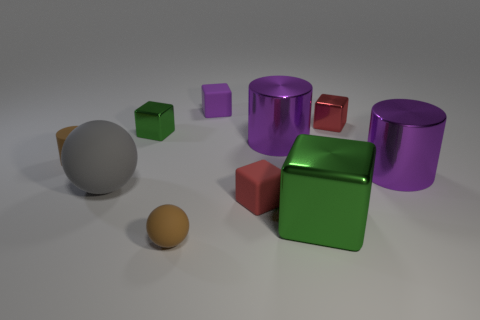What is the material of the small thing that is the same color as the tiny cylinder?
Offer a terse response. Rubber. What is the material of the other thing that is the same shape as the gray matte object?
Give a very brief answer. Rubber. Do the matte cylinder to the left of the tiny purple thing and the small sphere have the same color?
Your answer should be very brief. Yes. Are there the same number of brown matte cylinders that are behind the tiny matte cylinder and brown objects?
Give a very brief answer. No. Are there any large rubber objects that have the same color as the large block?
Ensure brevity in your answer.  No. Does the brown ball have the same size as the brown cylinder?
Give a very brief answer. Yes. There is a green metallic block on the left side of the green cube that is in front of the brown rubber cylinder; how big is it?
Provide a succinct answer. Small. There is a rubber thing that is in front of the large matte thing and behind the small brown sphere; what is its size?
Provide a short and direct response. Small. What number of cyan balls are the same size as the purple rubber object?
Offer a terse response. 0. What number of shiny objects are tiny yellow spheres or gray balls?
Make the answer very short. 0. 